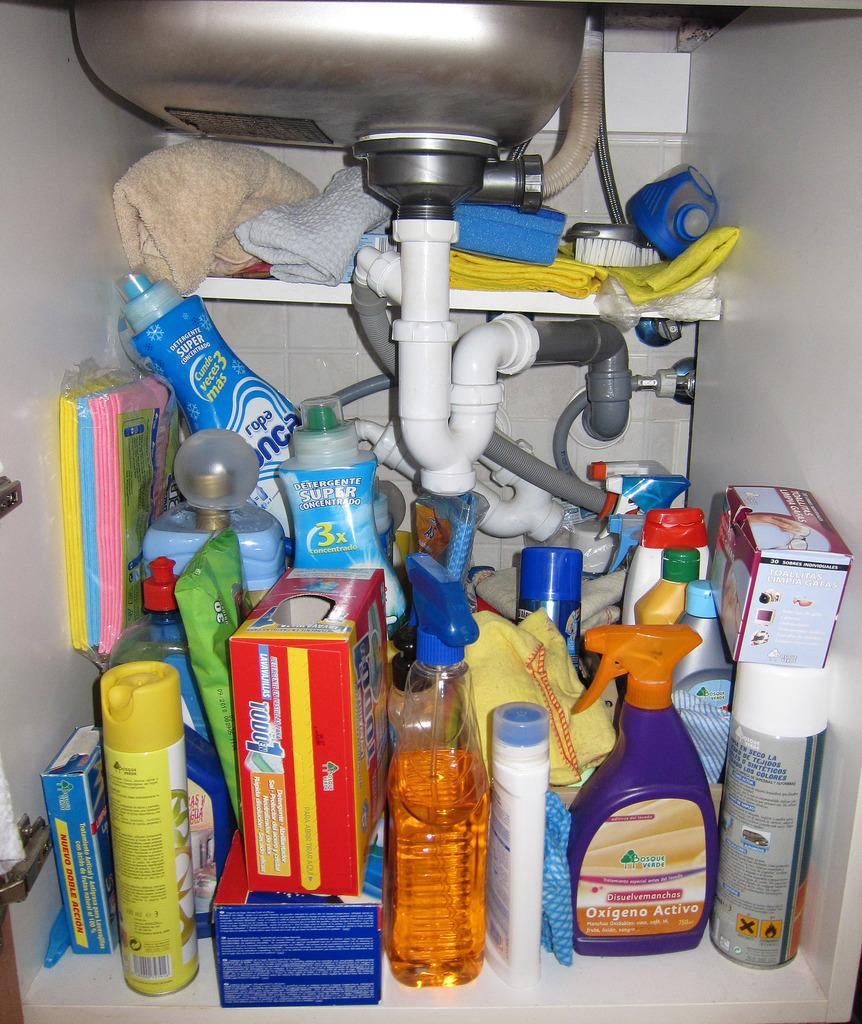What is located under the sink in the image? There are articles under the sink in the image. How are the articles arranged under the sink? The articles are improperly arranged. What type of cloth is draped over the edge of the sink in the image? There is no cloth present in the image, and the edge of the sink is not mentioned in the provided facts. 